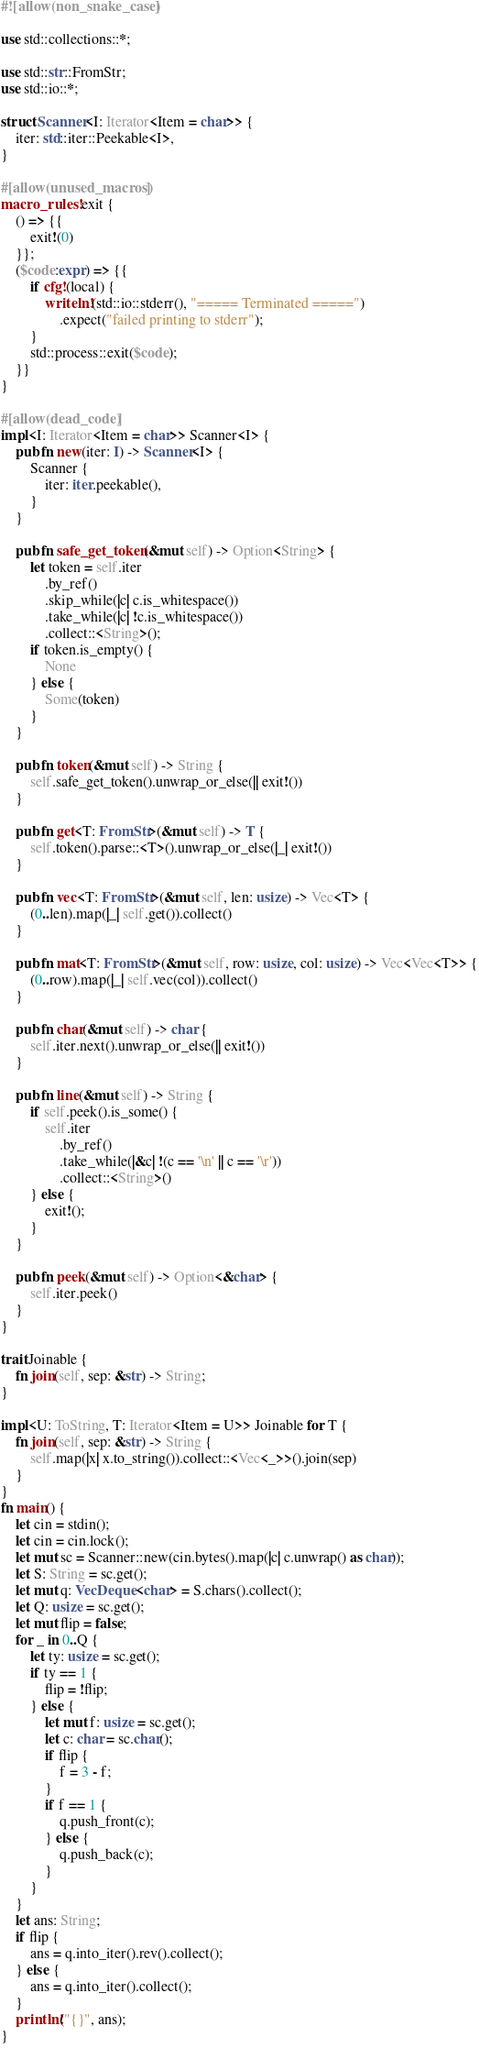Convert code to text. <code><loc_0><loc_0><loc_500><loc_500><_Rust_>#![allow(non_snake_case)]

use std::collections::*;

use std::str::FromStr;
use std::io::*;

struct Scanner<I: Iterator<Item = char>> {
    iter: std::iter::Peekable<I>,
}

#[allow(unused_macros)]
macro_rules! exit {
    () => {{
        exit!(0)
    }};
    ($code:expr) => {{
        if cfg!(local) {
            writeln!(std::io::stderr(), "===== Terminated =====")
                .expect("failed printing to stderr");
        }
        std::process::exit($code);
    }}
}

#[allow(dead_code)]
impl<I: Iterator<Item = char>> Scanner<I> {
    pub fn new(iter: I) -> Scanner<I> {
        Scanner {
            iter: iter.peekable(),
        }
    }

    pub fn safe_get_token(&mut self) -> Option<String> {
        let token = self.iter
            .by_ref()
            .skip_while(|c| c.is_whitespace())
            .take_while(|c| !c.is_whitespace())
            .collect::<String>();
        if token.is_empty() {
            None
        } else {
            Some(token)
        }
    }

    pub fn token(&mut self) -> String {
        self.safe_get_token().unwrap_or_else(|| exit!())
    }

    pub fn get<T: FromStr>(&mut self) -> T {
        self.token().parse::<T>().unwrap_or_else(|_| exit!())
    }

    pub fn vec<T: FromStr>(&mut self, len: usize) -> Vec<T> {
        (0..len).map(|_| self.get()).collect()
    }

    pub fn mat<T: FromStr>(&mut self, row: usize, col: usize) -> Vec<Vec<T>> {
        (0..row).map(|_| self.vec(col)).collect()
    }

    pub fn char(&mut self) -> char {
        self.iter.next().unwrap_or_else(|| exit!())
    }

    pub fn line(&mut self) -> String {
        if self.peek().is_some() {
            self.iter
                .by_ref()
                .take_while(|&c| !(c == '\n' || c == '\r'))
                .collect::<String>()
        } else {
            exit!();
        }
    }

    pub fn peek(&mut self) -> Option<&char> {
        self.iter.peek()
    }
}

trait Joinable {
    fn join(self, sep: &str) -> String;
}

impl<U: ToString, T: Iterator<Item = U>> Joinable for T {
    fn join(self, sep: &str) -> String {
        self.map(|x| x.to_string()).collect::<Vec<_>>().join(sep)
    }
}
fn main() {
    let cin = stdin();
    let cin = cin.lock();
    let mut sc = Scanner::new(cin.bytes().map(|c| c.unwrap() as char));
    let S: String = sc.get();
    let mut q: VecDeque<char> = S.chars().collect();
    let Q: usize = sc.get();
    let mut flip = false;
    for _ in 0..Q {
        let ty: usize = sc.get();
        if ty == 1 {
            flip = !flip;
        } else {
            let mut f: usize = sc.get();
            let c: char = sc.char();
            if flip {
                f = 3 - f;
            }
            if f == 1 {
                q.push_front(c);
            } else {
                q.push_back(c);
            }
        }
    }
    let ans: String;
    if flip {
        ans = q.into_iter().rev().collect();
    } else {
        ans = q.into_iter().collect();
    }
    println!("{}", ans);
}
</code> 